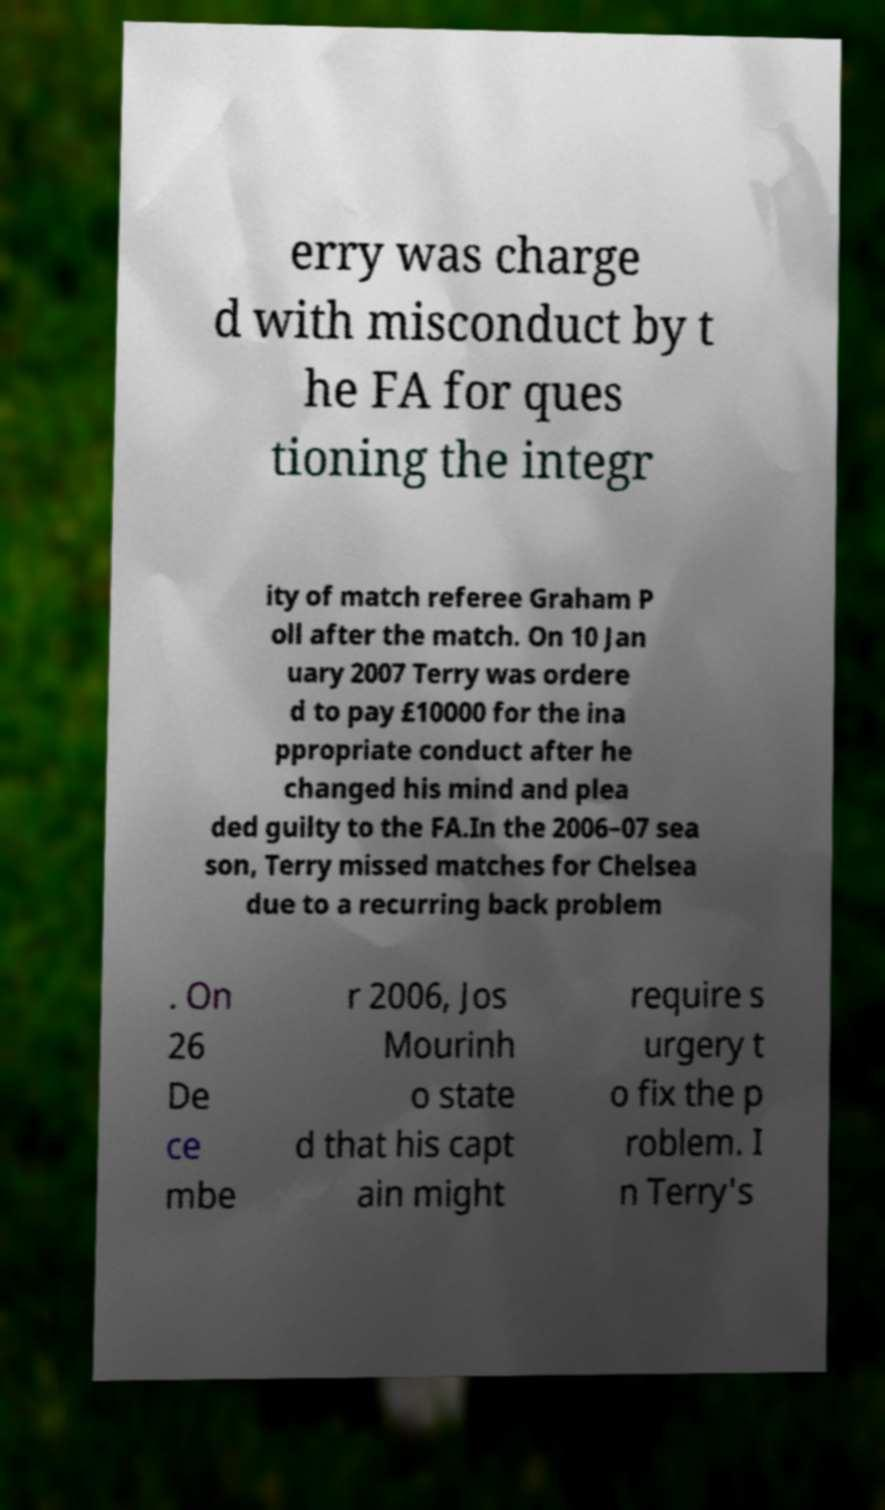Can you accurately transcribe the text from the provided image for me? erry was charge d with misconduct by t he FA for ques tioning the integr ity of match referee Graham P oll after the match. On 10 Jan uary 2007 Terry was ordere d to pay £10000 for the ina ppropriate conduct after he changed his mind and plea ded guilty to the FA.In the 2006–07 sea son, Terry missed matches for Chelsea due to a recurring back problem . On 26 De ce mbe r 2006, Jos Mourinh o state d that his capt ain might require s urgery t o fix the p roblem. I n Terry's 